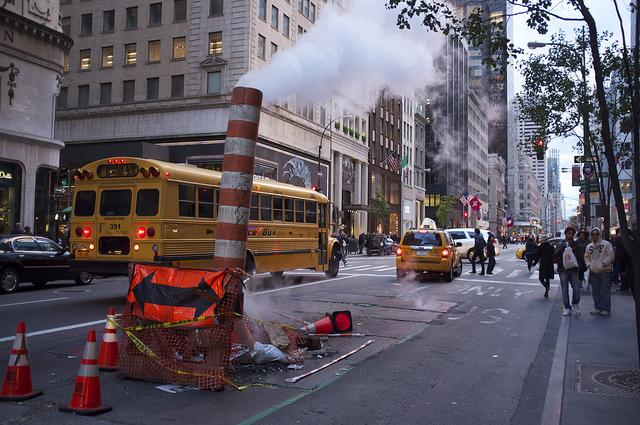What is the long vehicle for? Please explain your reasoning. transporting children. The long vehicle is a yellow school bus. 